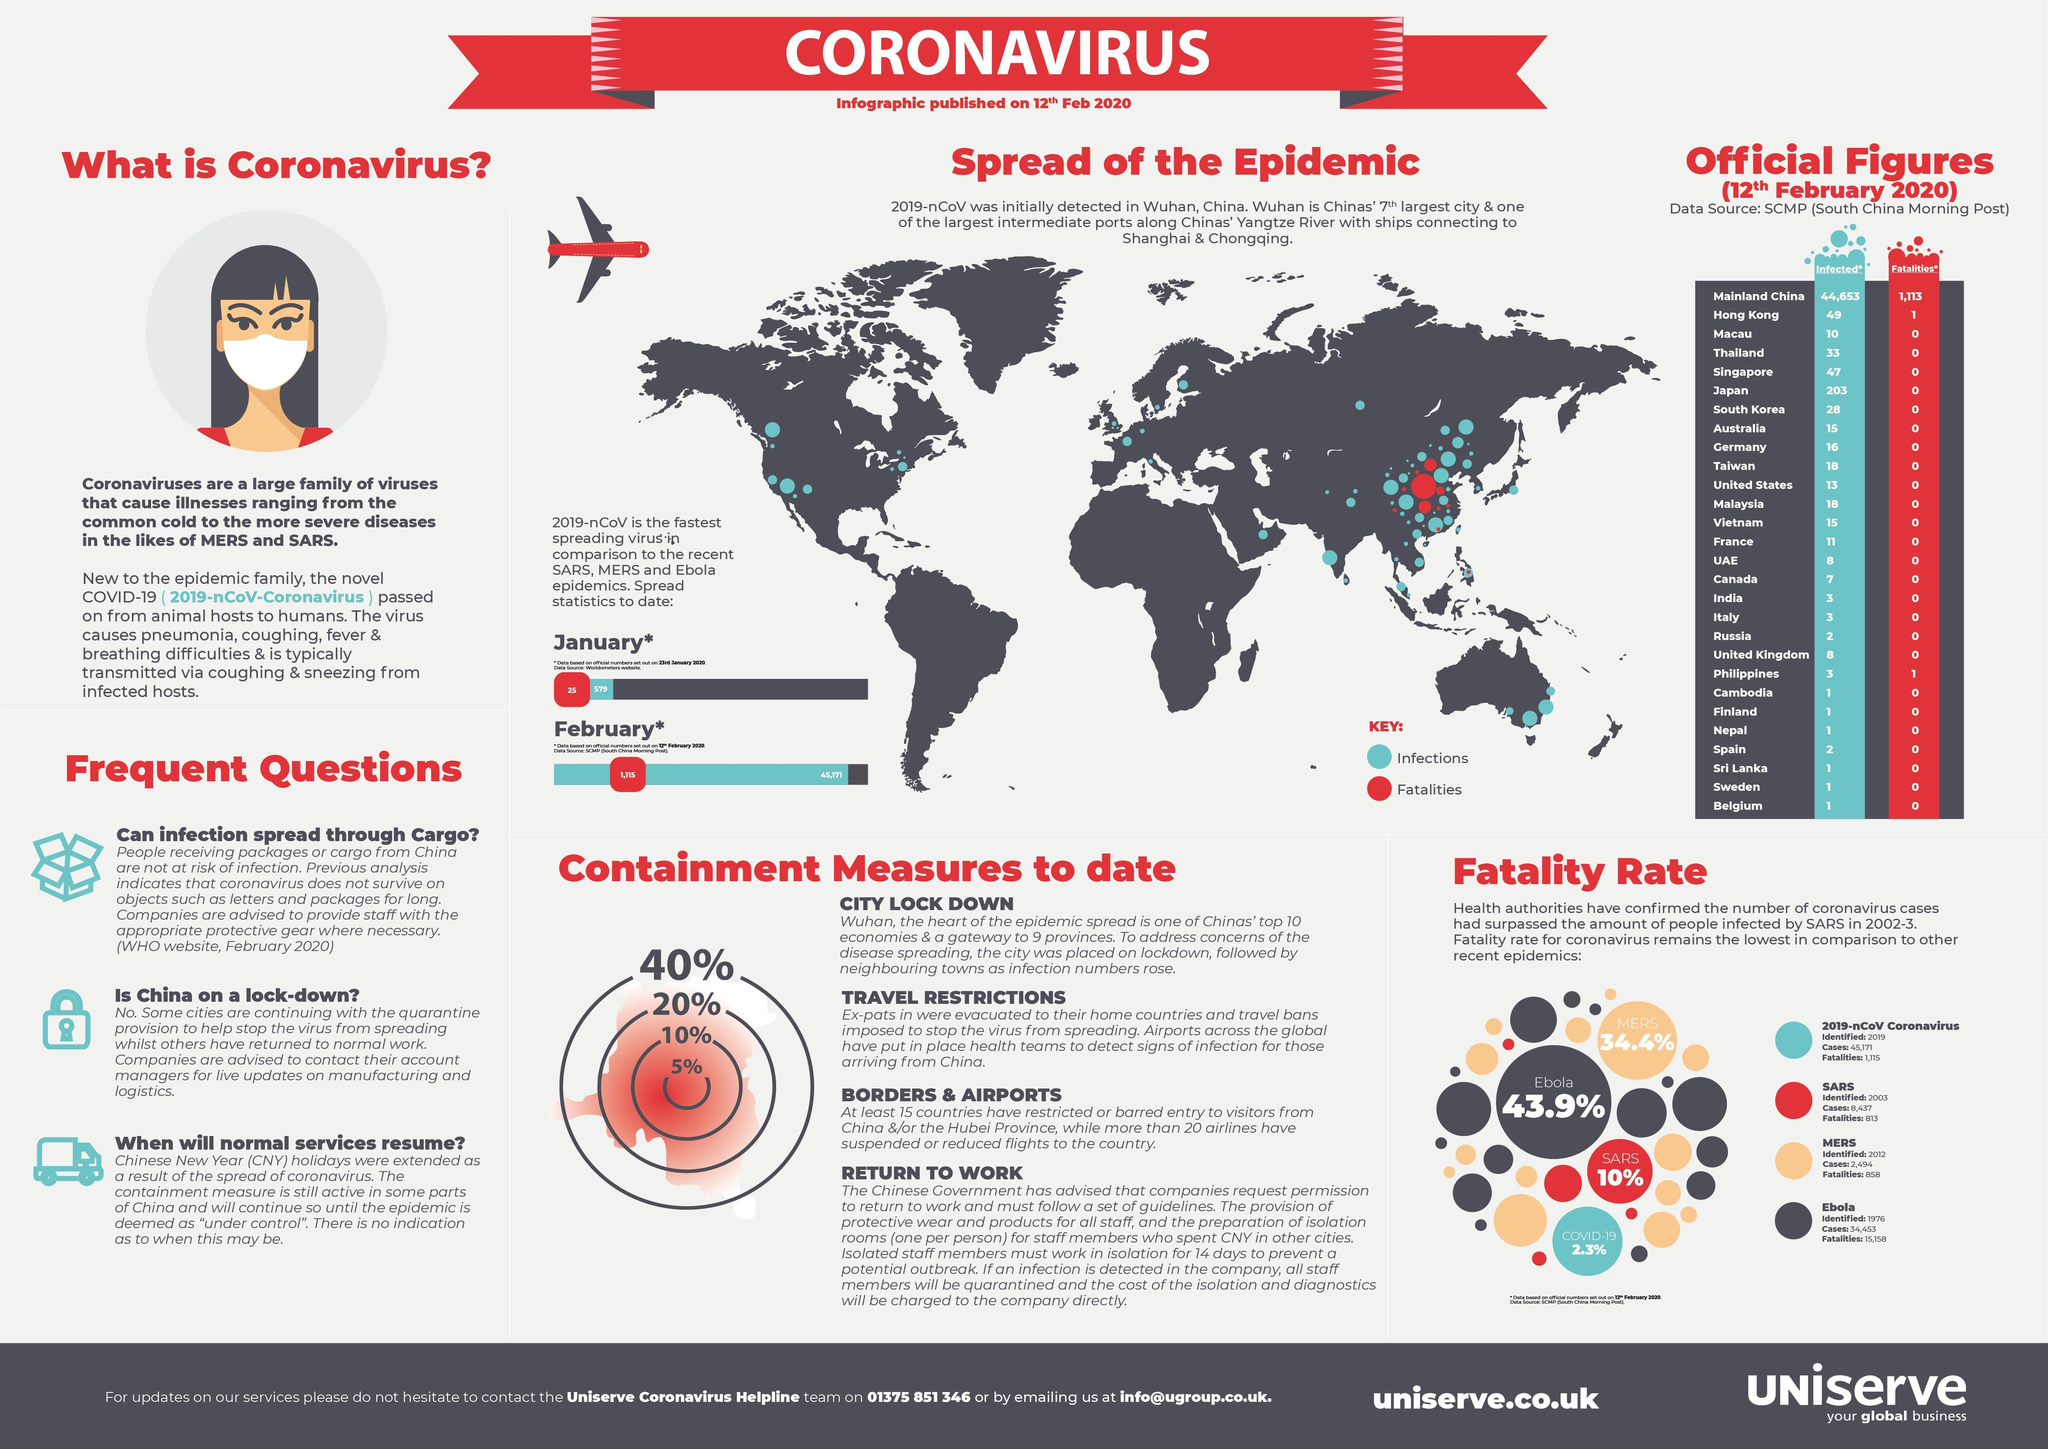What is the fatality rate caused by the SARS virus as of February 12, 2020?
Answer the question with a short phrase. 10% When was the Ebola virus first discovered? 1976 How many Covid-19 deaths were reported in the Mainland China as of February 12, 2020? 1,113 Which country has reported the highest fatality rate due to Covid-19 as of February 12, 2020? Mainland China How many Covid-19 deaths were reported in UAE as of February 12, 2020? 0 How many Covid-19 deaths were reported in the Hong kong as of February 12, 2020? 1 What is the fatality rate due to the Ebola virus as of February 12, 2020? 43.9% What is the total number of COVID-19 cases reported in the UK as of February 12, 2020? 8 What is the total number of COVID-19 cases reported in Japan as of February 12, 2020? 203 Where was the first case of the coronavirus disease identified? Wuhan, China 